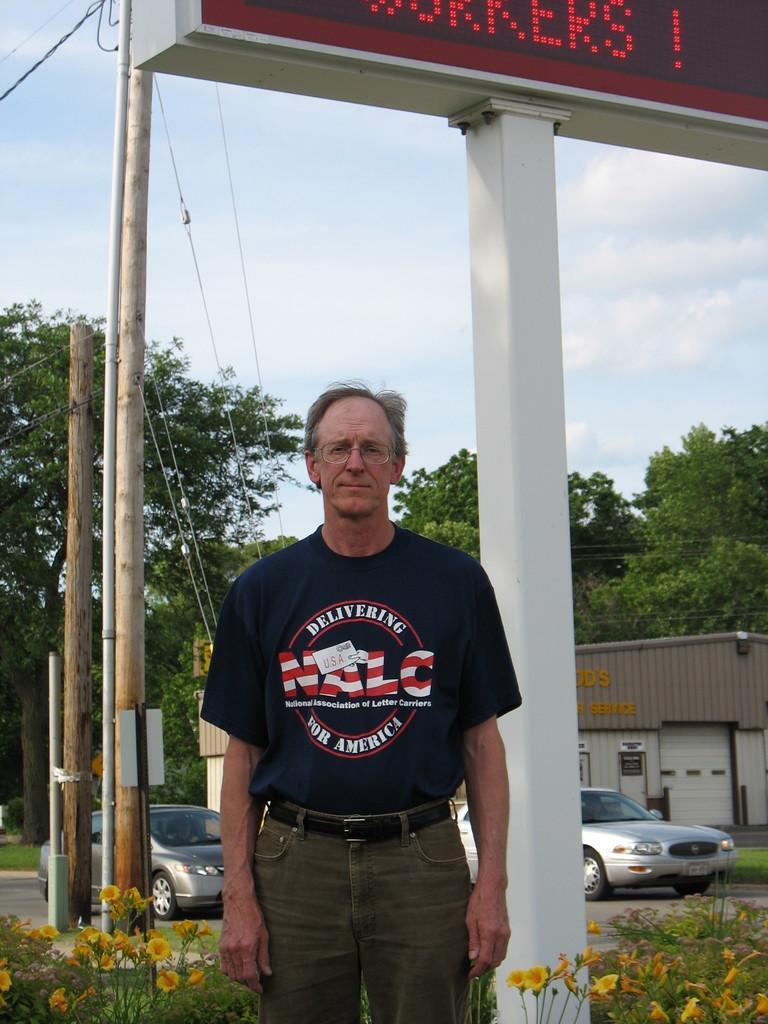In one or two sentences, can you explain what this image depicts? In this image, a person is standing and wearing glasses. At the bottom, we can see flowers, plants, few vehicles are on the road. Background there are few poles, pillars, trees, shed, poster, board, wire. Top of the image, there is a cloudy sky and hoarding. Here we can see a digital screen. 